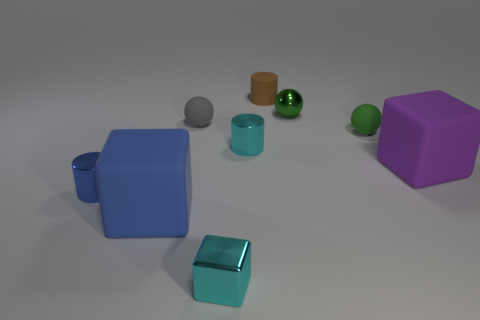Subtract 0 brown blocks. How many objects are left? 9 Subtract all balls. How many objects are left? 6 Subtract 2 blocks. How many blocks are left? 1 Subtract all blue spheres. Subtract all cyan cylinders. How many spheres are left? 3 Subtract all blue spheres. How many cyan cylinders are left? 1 Subtract all red shiny cylinders. Subtract all blue rubber blocks. How many objects are left? 8 Add 6 cyan blocks. How many cyan blocks are left? 7 Add 4 tiny blue cylinders. How many tiny blue cylinders exist? 5 Add 1 tiny gray balls. How many objects exist? 10 Subtract all green balls. How many balls are left? 1 